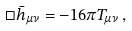Convert formula to latex. <formula><loc_0><loc_0><loc_500><loc_500>\Box { \bar { h } } _ { \mu \nu } = - 1 6 \pi T _ { \mu \nu } \, ,</formula> 